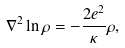Convert formula to latex. <formula><loc_0><loc_0><loc_500><loc_500>\nabla ^ { 2 } \ln \rho = - \frac { 2 e ^ { 2 } } { \kappa } \rho ,</formula> 